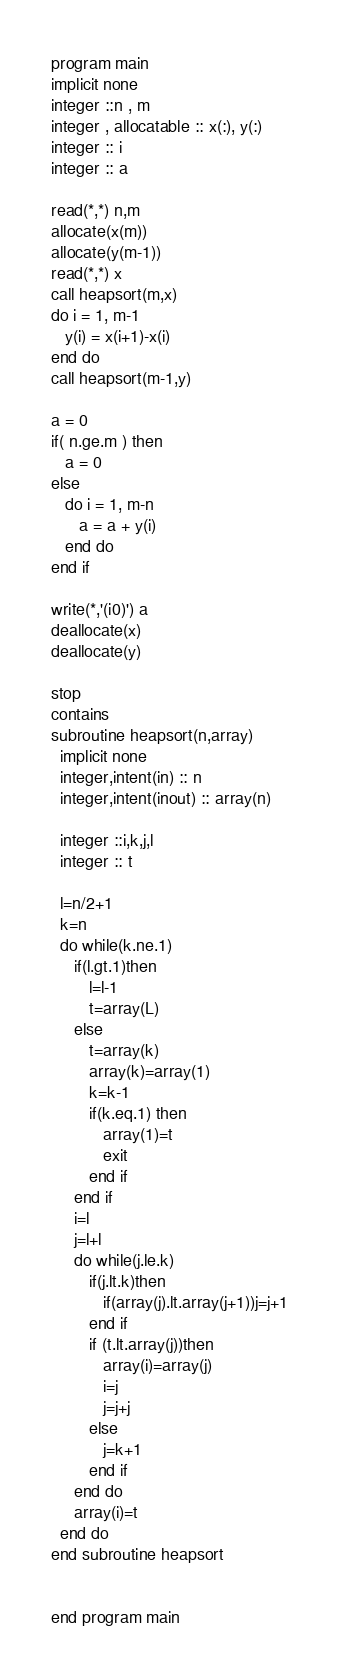<code> <loc_0><loc_0><loc_500><loc_500><_FORTRAN_>program main
implicit none
integer ::n , m
integer , allocatable :: x(:), y(:)
integer :: i
integer :: a

read(*,*) n,m 
allocate(x(m))
allocate(y(m-1))
read(*,*) x
call heapsort(m,x)
do i = 1, m-1
   y(i) = x(i+1)-x(i)
end do
call heapsort(m-1,y)

a = 0
if( n.ge.m ) then
   a = 0
else
   do i = 1, m-n
      a = a + y(i)
   end do
end if

write(*,'(i0)') a
deallocate(x)
deallocate(y)

stop
contains
subroutine heapsort(n,array)
  implicit none
  integer,intent(in) :: n
  integer,intent(inout) :: array(n)
  
  integer ::i,k,j,l
  integer :: t

  l=n/2+1
  k=n
  do while(k.ne.1)
     if(l.gt.1)then
        l=l-1
        t=array(L)
     else
        t=array(k)
        array(k)=array(1)
        k=k-1
        if(k.eq.1) then
           array(1)=t
           exit
        end if
     end if
     i=l
     j=l+l
     do while(j.le.k)
        if(j.lt.k)then
           if(array(j).lt.array(j+1))j=j+1
        end if
        if (t.lt.array(j))then
           array(i)=array(j)
           i=j
           j=j+j
        else
           j=k+1
        end if
     end do
     array(i)=t
  end do
end subroutine heapsort


end program main
</code> 